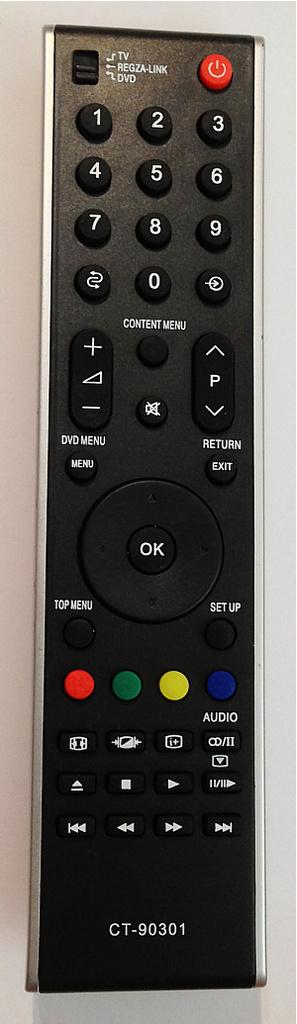<image>
Summarize the visual content of the image. DVD and TV remote with audio and other menu content. 